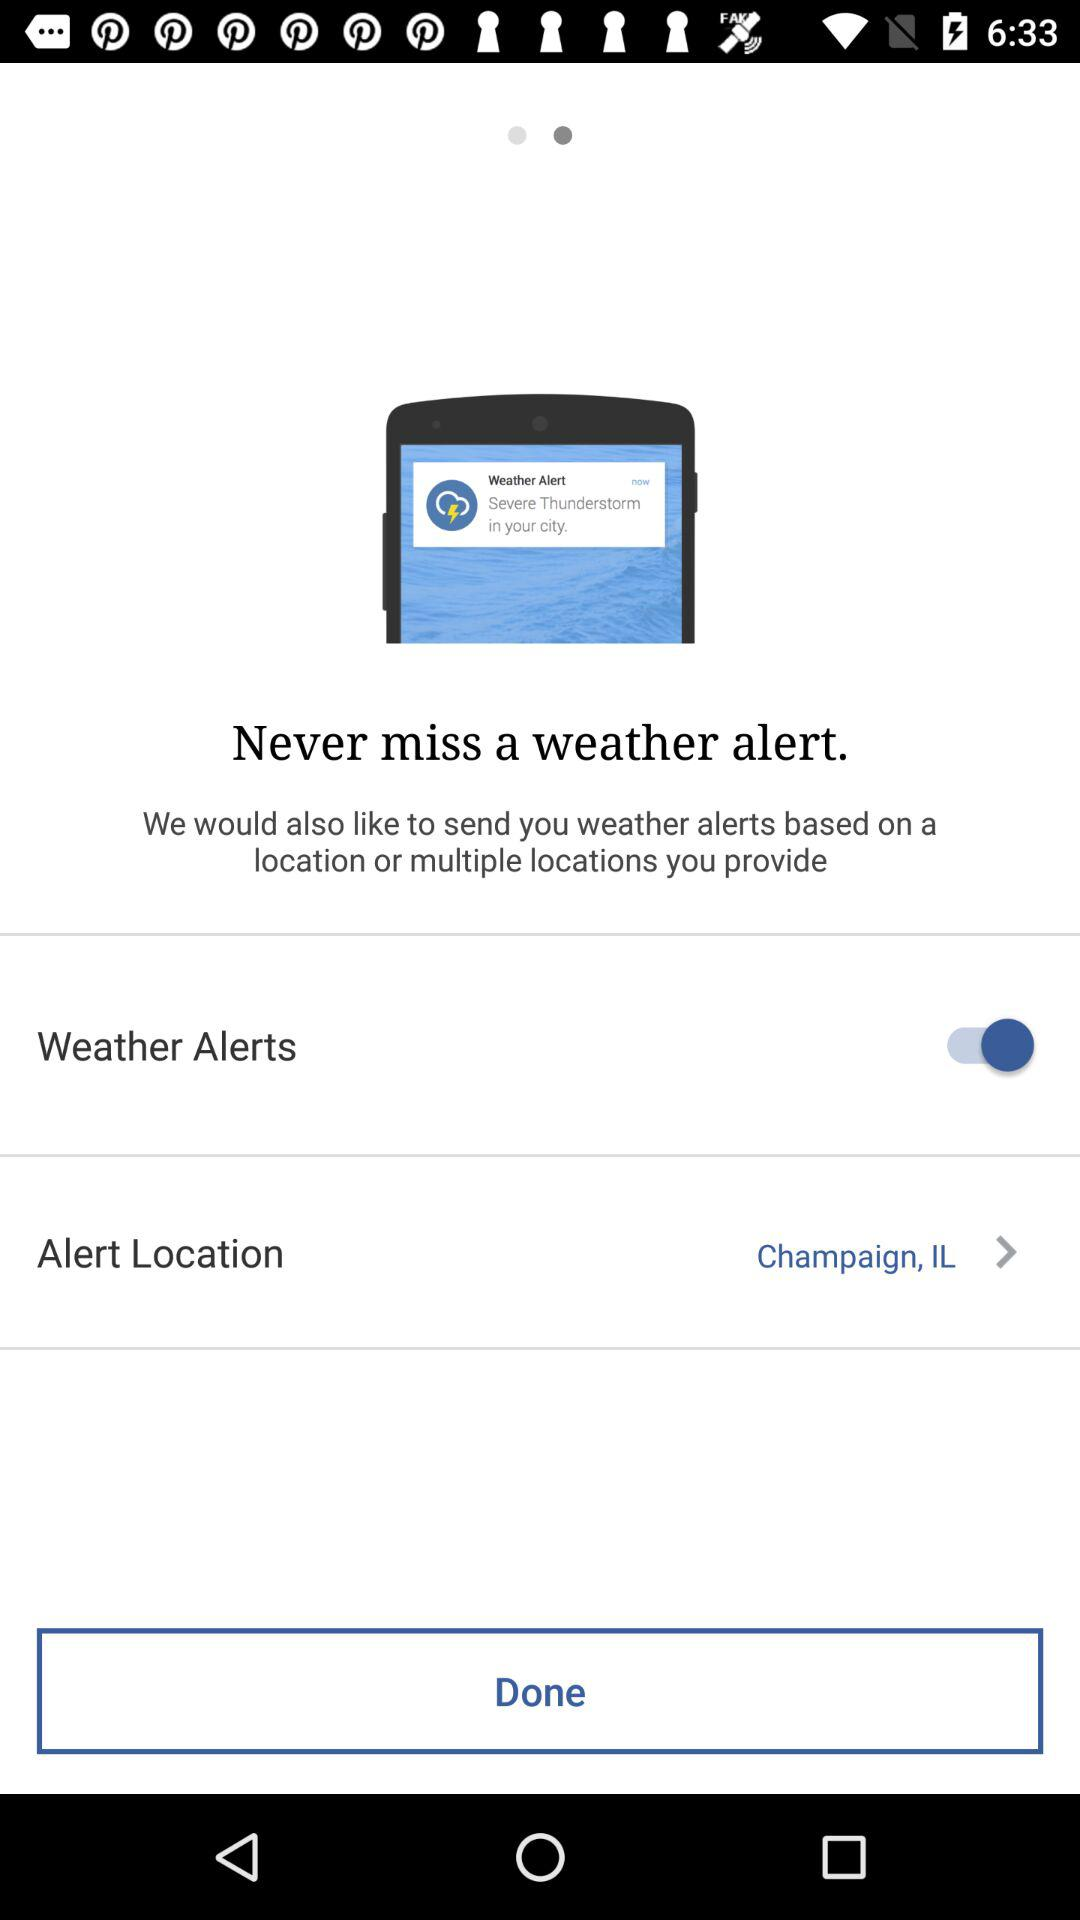What is the selected alert location? The selected alert location is Champaign, IL. 